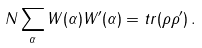Convert formula to latex. <formula><loc_0><loc_0><loc_500><loc_500>N \sum _ { \alpha } W ( \alpha ) W ^ { \prime } ( \alpha ) = t r ( \rho \rho ^ { \prime } ) \, .</formula> 